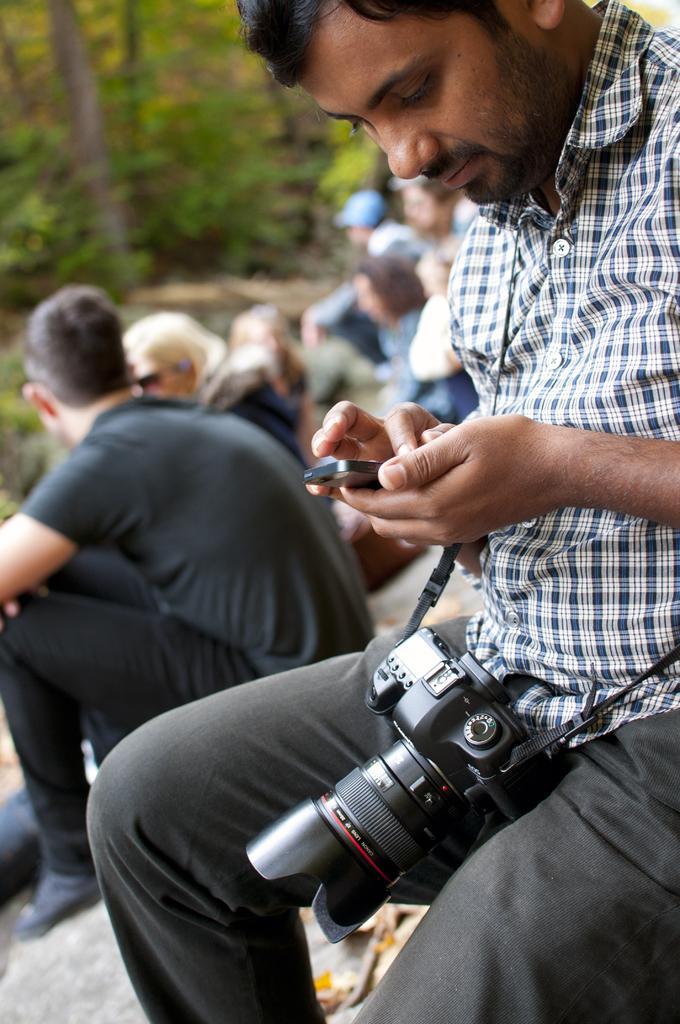Can you describe this image briefly? In the foreground of the image there is a person wearing a camera, Holding a mobile phone in his hand. In the background of the image there are people sitting on stones. There are trees. 